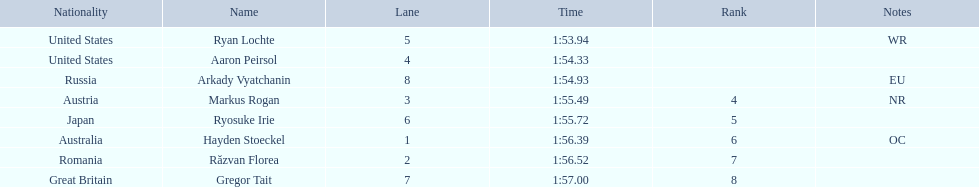What is the name of the contestant in lane 6? Ryosuke Irie. How long did it take that player to complete the race? 1:55.72. 